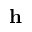<formula> <loc_0><loc_0><loc_500><loc_500>h</formula> 